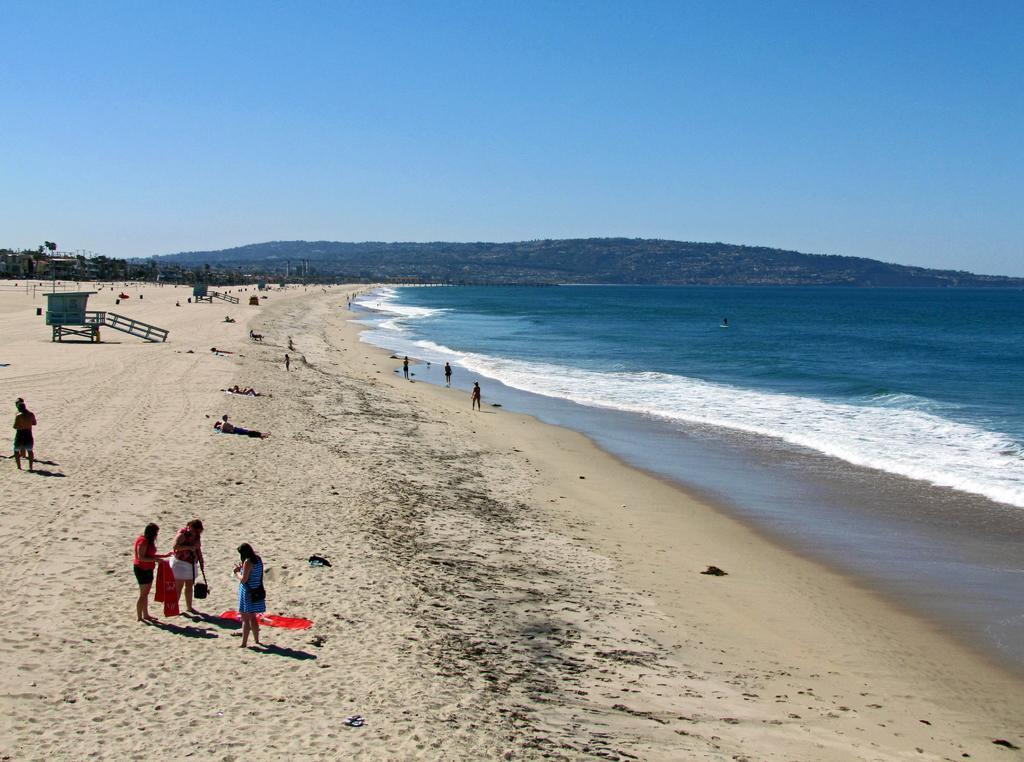How would you summarize this image in a sentence or two? In the image we can see there are people standing and others are lying on the sand. There are small buildings and there is an ocean. Behind there are mountains and background of the image is little blurred. There is a clear sky. 